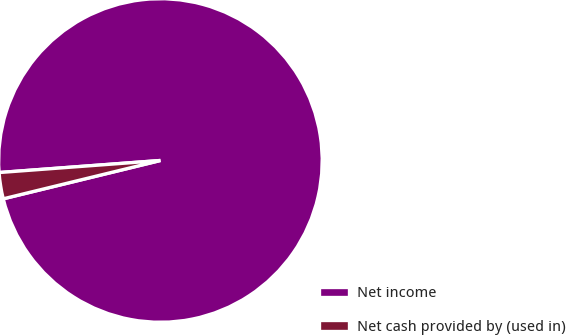Convert chart. <chart><loc_0><loc_0><loc_500><loc_500><pie_chart><fcel>Net income<fcel>Net cash provided by (used in)<nl><fcel>97.38%<fcel>2.62%<nl></chart> 